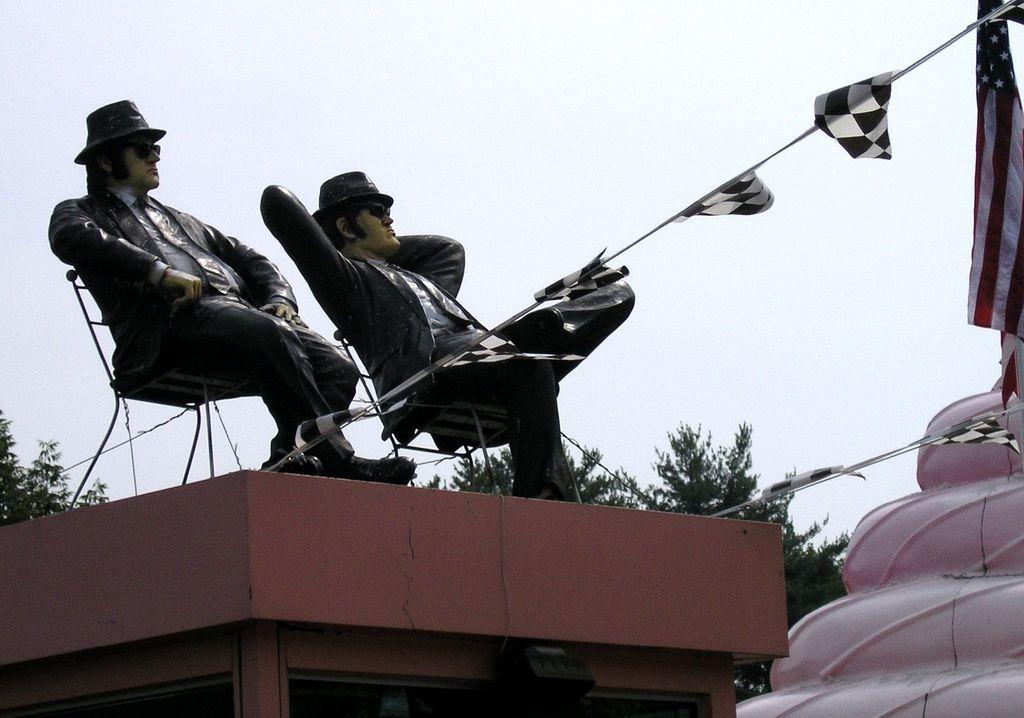What can be seen on the building in the foreground of the image? There are two statues on a building in the foreground. What else is visible in the image besides the statues? Flags are visible in the image. What is the color of the structure in the image? There is a pink structure in the image. What can be seen in the background of the image? There are trees and the sky visible in the background of the image. How many chairs are placed near the pink structure in the image? There are no chairs visible in the image; only the statues, flags, trees, and sky are present. Can you describe the toes of the statues in the image? There are no visible toes in the image, as the statues are not depicted in a way that shows their feet or toes. 